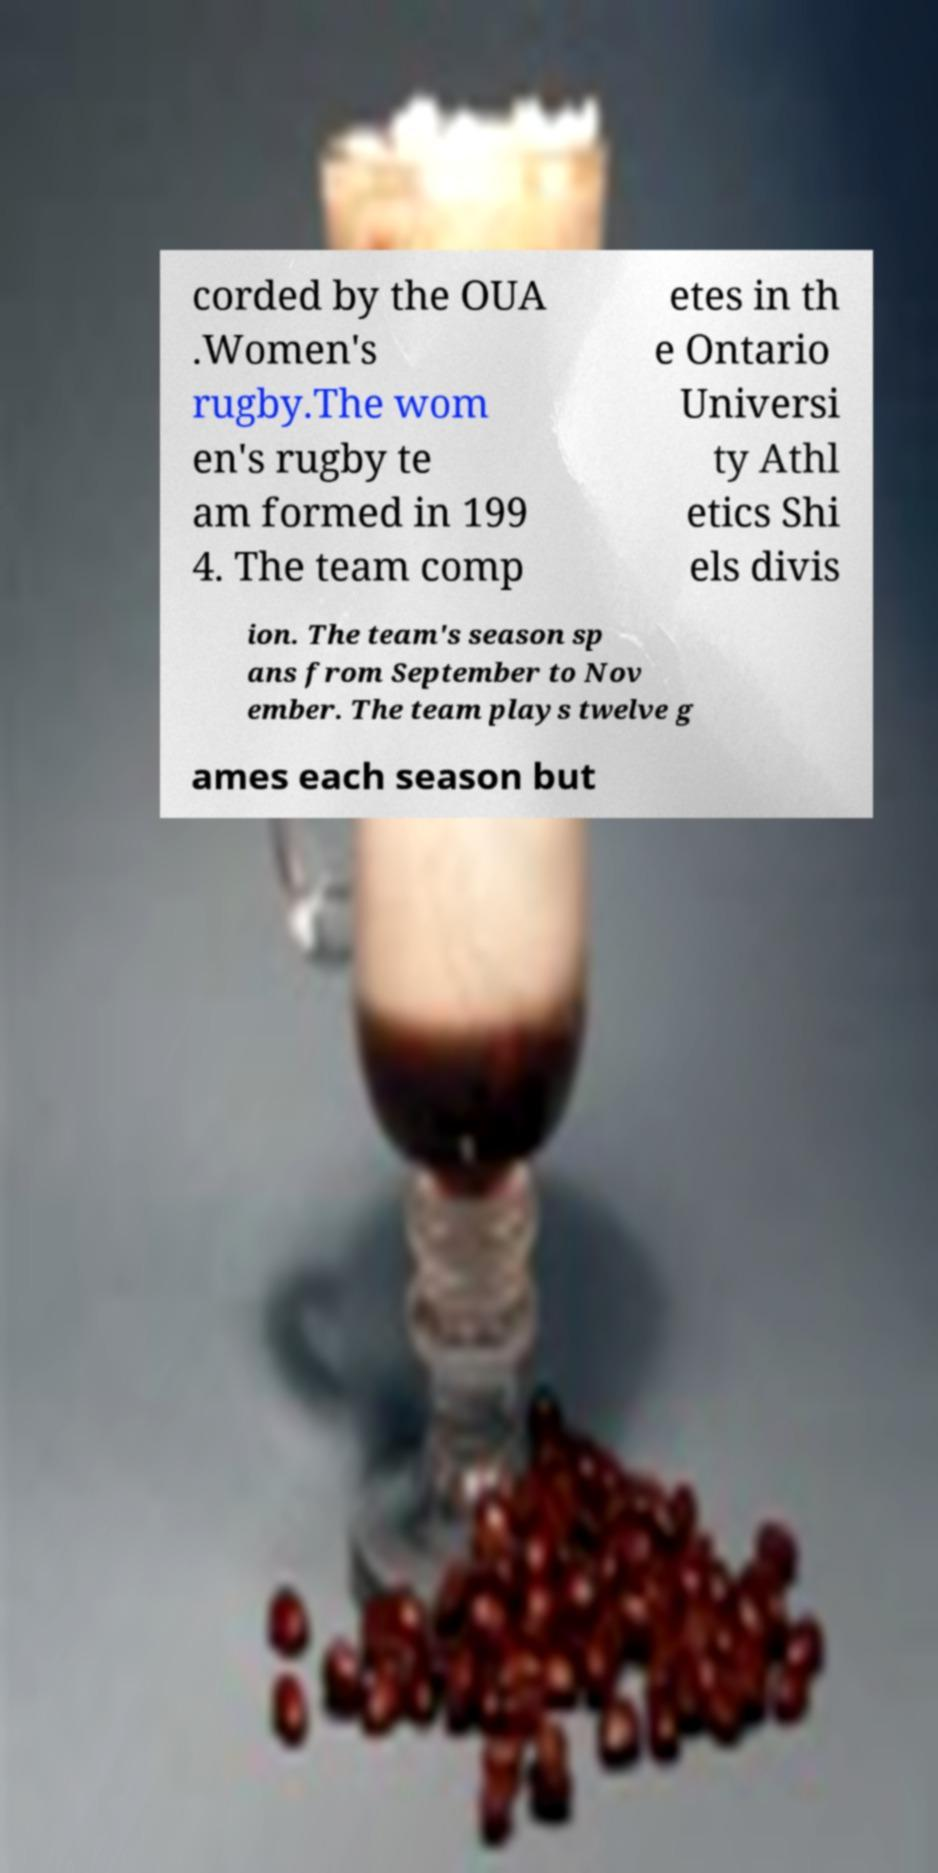Could you extract and type out the text from this image? corded by the OUA .Women's rugby.The wom en's rugby te am formed in 199 4. The team comp etes in th e Ontario Universi ty Athl etics Shi els divis ion. The team's season sp ans from September to Nov ember. The team plays twelve g ames each season but 